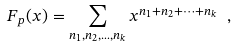Convert formula to latex. <formula><loc_0><loc_0><loc_500><loc_500>F _ { p } ( x ) = \sum _ { n _ { 1 } , n _ { 2 } , \dots , n _ { k } } x ^ { n _ { 1 } + n _ { 2 } + \dots + n _ { k } } \ ,</formula> 